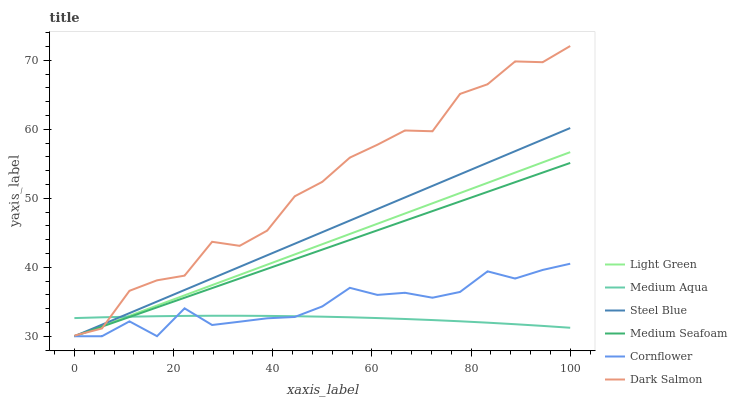Does Medium Aqua have the minimum area under the curve?
Answer yes or no. Yes. Does Dark Salmon have the maximum area under the curve?
Answer yes or no. Yes. Does Steel Blue have the minimum area under the curve?
Answer yes or no. No. Does Steel Blue have the maximum area under the curve?
Answer yes or no. No. Is Medium Seafoam the smoothest?
Answer yes or no. Yes. Is Dark Salmon the roughest?
Answer yes or no. Yes. Is Steel Blue the smoothest?
Answer yes or no. No. Is Steel Blue the roughest?
Answer yes or no. No. Does Cornflower have the lowest value?
Answer yes or no. Yes. Does Dark Salmon have the lowest value?
Answer yes or no. No. Does Dark Salmon have the highest value?
Answer yes or no. Yes. Does Steel Blue have the highest value?
Answer yes or no. No. Is Cornflower less than Dark Salmon?
Answer yes or no. Yes. Is Dark Salmon greater than Cornflower?
Answer yes or no. Yes. Does Cornflower intersect Medium Aqua?
Answer yes or no. Yes. Is Cornflower less than Medium Aqua?
Answer yes or no. No. Is Cornflower greater than Medium Aqua?
Answer yes or no. No. Does Cornflower intersect Dark Salmon?
Answer yes or no. No. 